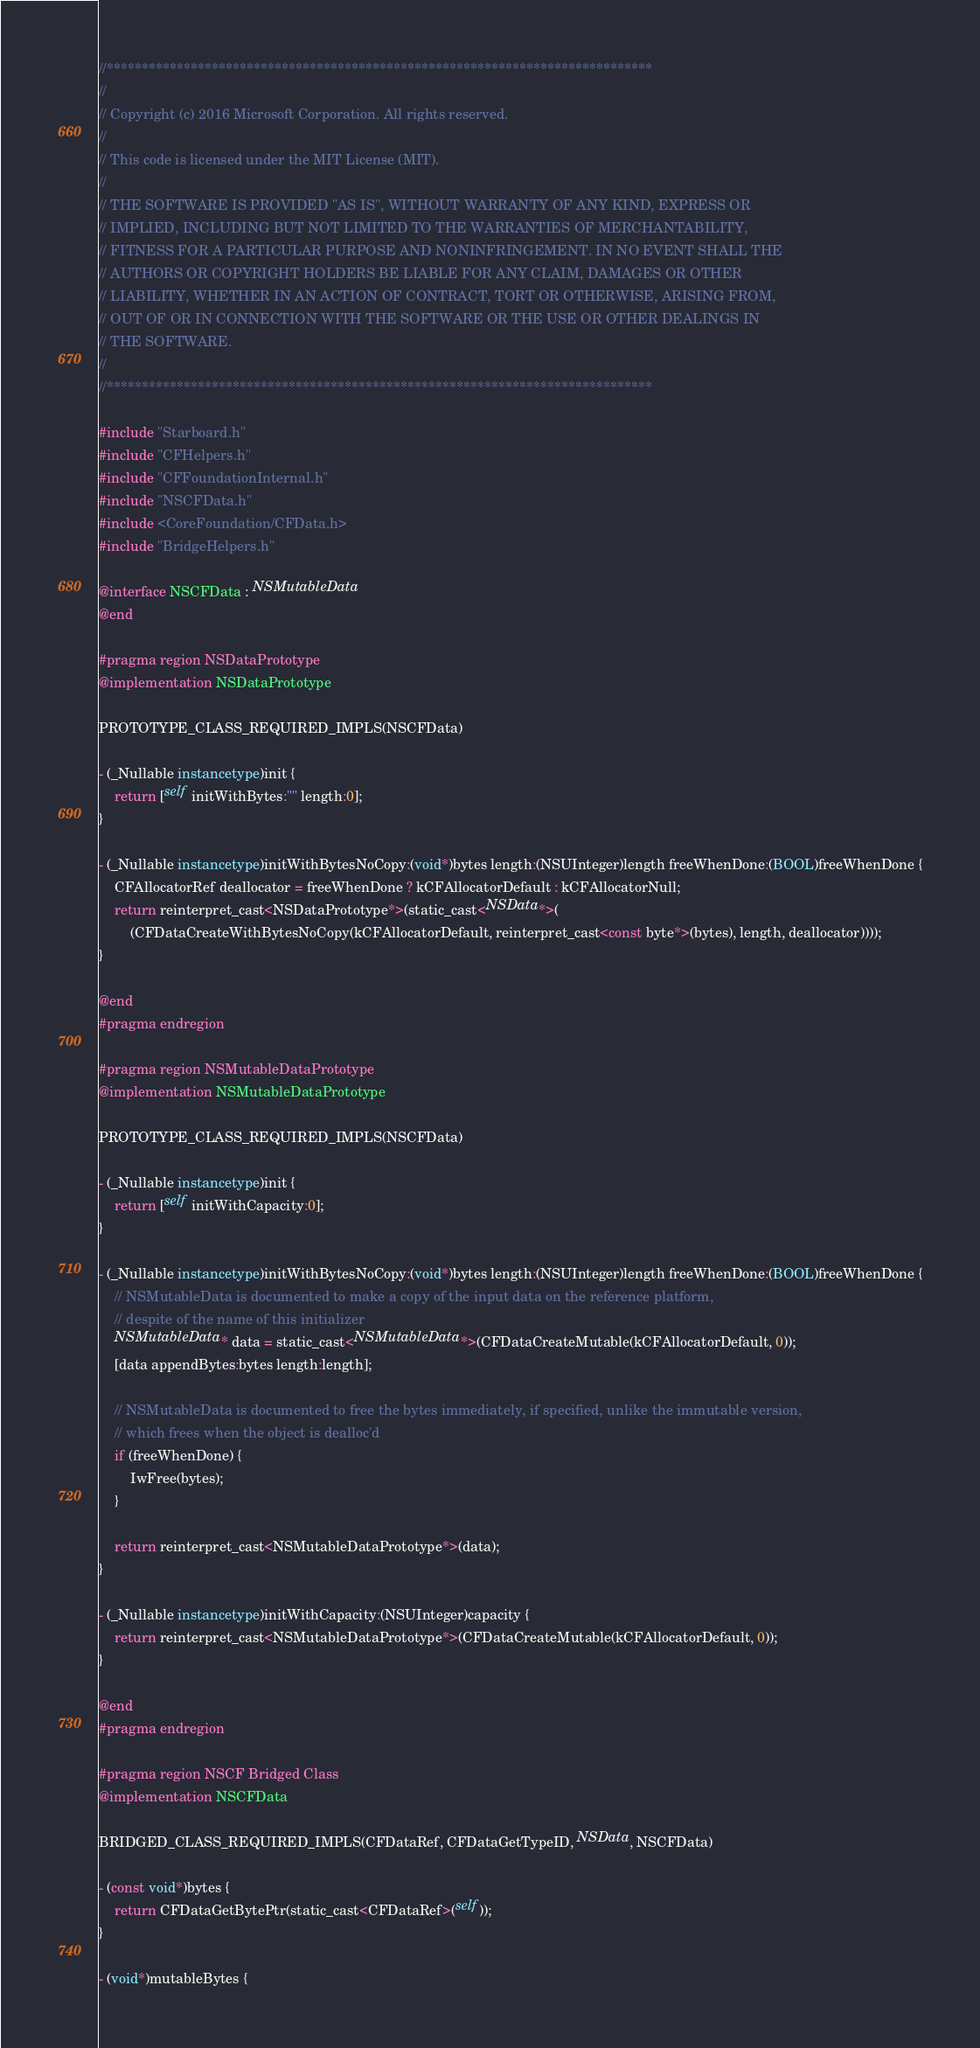Convert code to text. <code><loc_0><loc_0><loc_500><loc_500><_ObjectiveC_>//******************************************************************************
//
// Copyright (c) 2016 Microsoft Corporation. All rights reserved.
//
// This code is licensed under the MIT License (MIT).
//
// THE SOFTWARE IS PROVIDED "AS IS", WITHOUT WARRANTY OF ANY KIND, EXPRESS OR
// IMPLIED, INCLUDING BUT NOT LIMITED TO THE WARRANTIES OF MERCHANTABILITY,
// FITNESS FOR A PARTICULAR PURPOSE AND NONINFRINGEMENT. IN NO EVENT SHALL THE
// AUTHORS OR COPYRIGHT HOLDERS BE LIABLE FOR ANY CLAIM, DAMAGES OR OTHER
// LIABILITY, WHETHER IN AN ACTION OF CONTRACT, TORT OR OTHERWISE, ARISING FROM,
// OUT OF OR IN CONNECTION WITH THE SOFTWARE OR THE USE OR OTHER DEALINGS IN
// THE SOFTWARE.
//
//******************************************************************************

#include "Starboard.h"
#include "CFHelpers.h"
#include "CFFoundationInternal.h"
#include "NSCFData.h"
#include <CoreFoundation/CFData.h>
#include "BridgeHelpers.h"

@interface NSCFData : NSMutableData
@end

#pragma region NSDataPrototype
@implementation NSDataPrototype

PROTOTYPE_CLASS_REQUIRED_IMPLS(NSCFData)

- (_Nullable instancetype)init {
    return [self initWithBytes:"" length:0];
}

- (_Nullable instancetype)initWithBytesNoCopy:(void*)bytes length:(NSUInteger)length freeWhenDone:(BOOL)freeWhenDone {
    CFAllocatorRef deallocator = freeWhenDone ? kCFAllocatorDefault : kCFAllocatorNull;
    return reinterpret_cast<NSDataPrototype*>(static_cast<NSData*>(
        (CFDataCreateWithBytesNoCopy(kCFAllocatorDefault, reinterpret_cast<const byte*>(bytes), length, deallocator))));
}

@end
#pragma endregion

#pragma region NSMutableDataPrototype
@implementation NSMutableDataPrototype

PROTOTYPE_CLASS_REQUIRED_IMPLS(NSCFData)

- (_Nullable instancetype)init {
    return [self initWithCapacity:0];
}

- (_Nullable instancetype)initWithBytesNoCopy:(void*)bytes length:(NSUInteger)length freeWhenDone:(BOOL)freeWhenDone {
    // NSMutableData is documented to make a copy of the input data on the reference platform,
    // despite of the name of this initializer
    NSMutableData* data = static_cast<NSMutableData*>(CFDataCreateMutable(kCFAllocatorDefault, 0));
    [data appendBytes:bytes length:length];

    // NSMutableData is documented to free the bytes immediately, if specified, unlike the immutable version,
    // which frees when the object is dealloc'd
    if (freeWhenDone) {
        IwFree(bytes);
    }

    return reinterpret_cast<NSMutableDataPrototype*>(data);
}

- (_Nullable instancetype)initWithCapacity:(NSUInteger)capacity {
    return reinterpret_cast<NSMutableDataPrototype*>(CFDataCreateMutable(kCFAllocatorDefault, 0));
}

@end
#pragma endregion

#pragma region NSCF Bridged Class
@implementation NSCFData

BRIDGED_CLASS_REQUIRED_IMPLS(CFDataRef, CFDataGetTypeID, NSData, NSCFData)

- (const void*)bytes {
    return CFDataGetBytePtr(static_cast<CFDataRef>(self));
}

- (void*)mutableBytes {</code> 